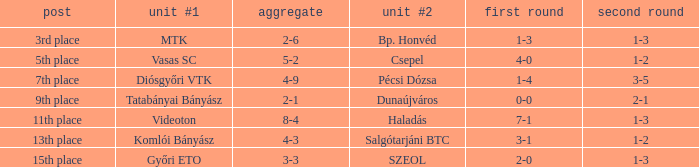What position has a 2-6 agg.? 3rd place. Help me parse the entirety of this table. {'header': ['post', 'unit #1', 'aggregate', 'unit #2', 'first round', 'second round'], 'rows': [['3rd place', 'MTK', '2-6', 'Bp. Honvéd', '1-3', '1-3'], ['5th place', 'Vasas SC', '5-2', 'Csepel', '4-0', '1-2'], ['7th place', 'Diósgyőri VTK', '4-9', 'Pécsi Dózsa', '1-4', '3-5'], ['9th place', 'Tatabányai Bányász', '2-1', 'Dunaújváros', '0-0', '2-1'], ['11th place', 'Videoton', '8-4', 'Haladás', '7-1', '1-3'], ['13th place', 'Komlói Bányász', '4-3', 'Salgótarjáni BTC', '3-1', '1-2'], ['15th place', 'Győri ETO', '3-3', 'SZEOL', '2-0', '1-3']]} 